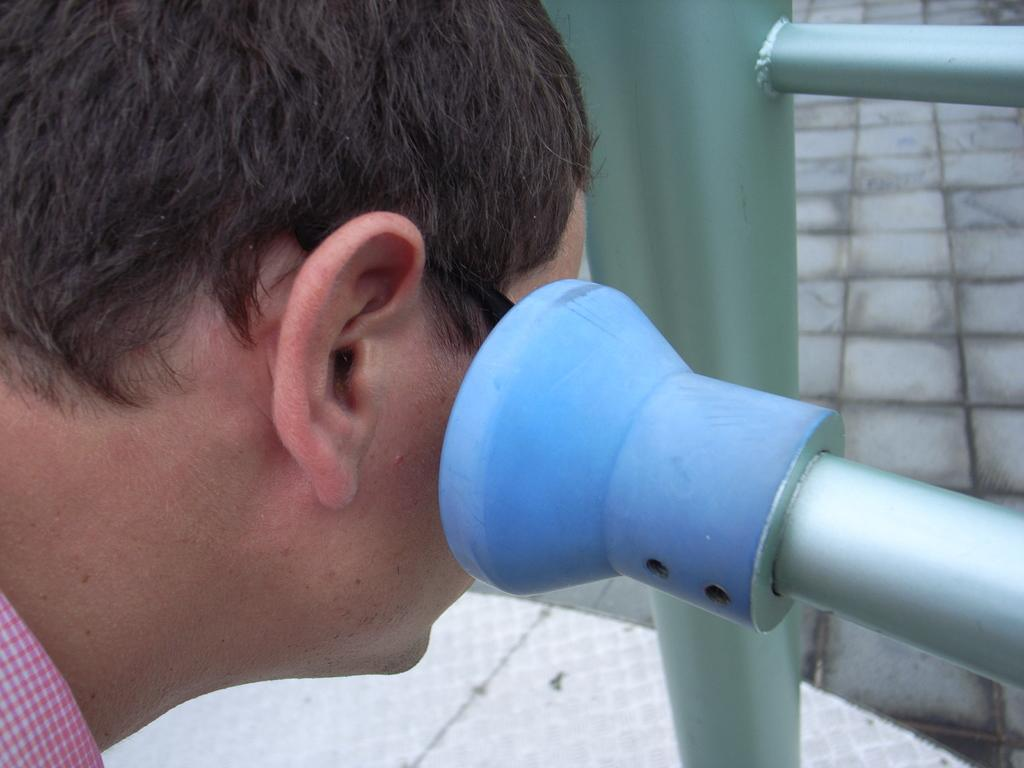What is the main object in the foreground of the picture? There is an iron frame in the foreground of the picture. Can you describe any human presence in the image? A person's face is visible on the left side of the image. What type of surface is visible at the bottom of the image? The bottom of the image features a floor. Are there any fairies visible in the image? There are no fairies present in the image. How does the person move around in the image? The person's face is visible, but there is no indication of movement in the image. 